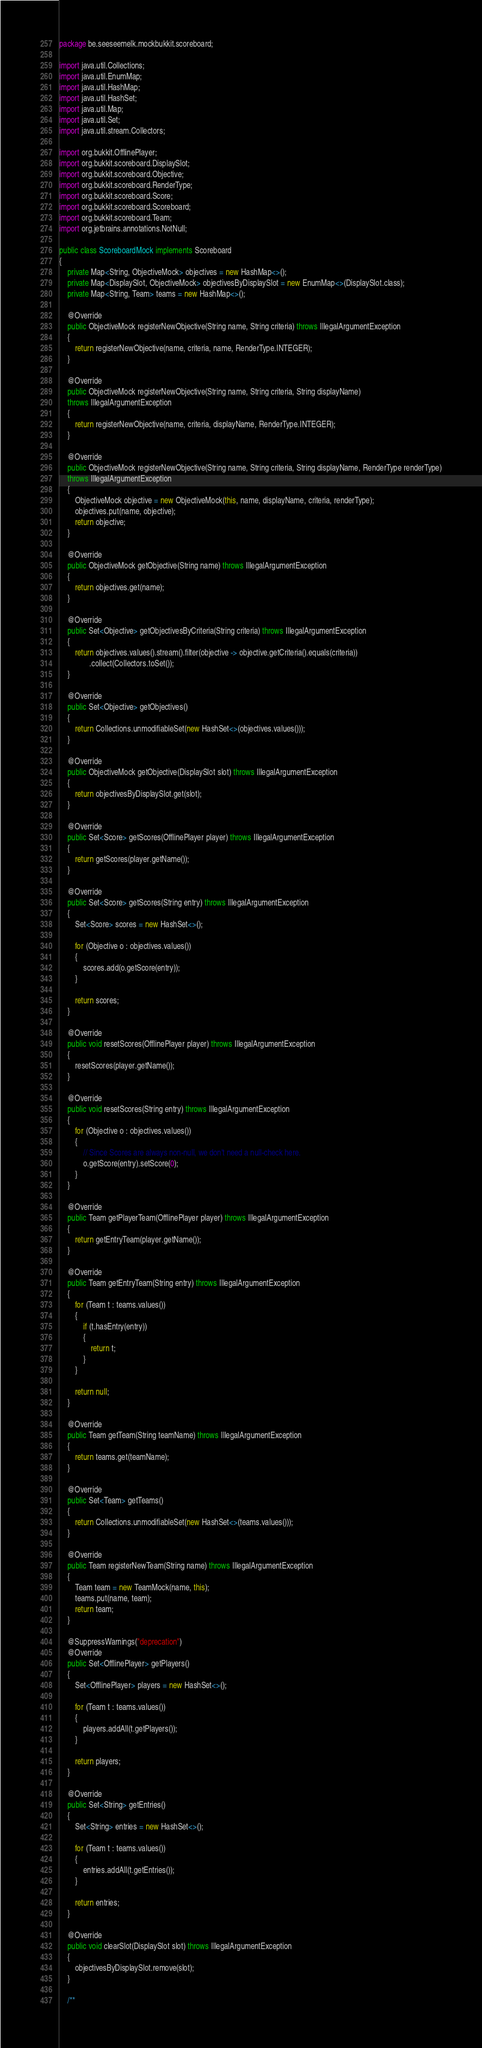Convert code to text. <code><loc_0><loc_0><loc_500><loc_500><_Java_>package be.seeseemelk.mockbukkit.scoreboard;

import java.util.Collections;
import java.util.EnumMap;
import java.util.HashMap;
import java.util.HashSet;
import java.util.Map;
import java.util.Set;
import java.util.stream.Collectors;

import org.bukkit.OfflinePlayer;
import org.bukkit.scoreboard.DisplaySlot;
import org.bukkit.scoreboard.Objective;
import org.bukkit.scoreboard.RenderType;
import org.bukkit.scoreboard.Score;
import org.bukkit.scoreboard.Scoreboard;
import org.bukkit.scoreboard.Team;
import org.jetbrains.annotations.NotNull;

public class ScoreboardMock implements Scoreboard
{
	private Map<String, ObjectiveMock> objectives = new HashMap<>();
	private Map<DisplaySlot, ObjectiveMock> objectivesByDisplaySlot = new EnumMap<>(DisplaySlot.class);
	private Map<String, Team> teams = new HashMap<>();

	@Override
	public ObjectiveMock registerNewObjective(String name, String criteria) throws IllegalArgumentException
	{
		return registerNewObjective(name, criteria, name, RenderType.INTEGER);
	}

	@Override
	public ObjectiveMock registerNewObjective(String name, String criteria, String displayName)
	throws IllegalArgumentException
	{
		return registerNewObjective(name, criteria, displayName, RenderType.INTEGER);
	}

	@Override
	public ObjectiveMock registerNewObjective(String name, String criteria, String displayName, RenderType renderType)
	throws IllegalArgumentException
	{
		ObjectiveMock objective = new ObjectiveMock(this, name, displayName, criteria, renderType);
		objectives.put(name, objective);
		return objective;
	}

	@Override
	public ObjectiveMock getObjective(String name) throws IllegalArgumentException
	{
		return objectives.get(name);
	}

	@Override
	public Set<Objective> getObjectivesByCriteria(String criteria) throws IllegalArgumentException
	{
		return objectives.values().stream().filter(objective -> objective.getCriteria().equals(criteria))
		       .collect(Collectors.toSet());
	}

	@Override
	public Set<Objective> getObjectives()
	{
		return Collections.unmodifiableSet(new HashSet<>(objectives.values()));
	}

	@Override
	public ObjectiveMock getObjective(DisplaySlot slot) throws IllegalArgumentException
	{
		return objectivesByDisplaySlot.get(slot);
	}

	@Override
	public Set<Score> getScores(OfflinePlayer player) throws IllegalArgumentException
	{
		return getScores(player.getName());
	}

	@Override
	public Set<Score> getScores(String entry) throws IllegalArgumentException
	{
		Set<Score> scores = new HashSet<>();

		for (Objective o : objectives.values())
		{
			scores.add(o.getScore(entry));
		}

		return scores;
	}

	@Override
	public void resetScores(OfflinePlayer player) throws IllegalArgumentException
	{
		resetScores(player.getName());
	}

	@Override
	public void resetScores(String entry) throws IllegalArgumentException
	{
		for (Objective o : objectives.values())
		{
			// Since Scores are always non-null, we don't need a null-check here.
			o.getScore(entry).setScore(0);
		}
	}

	@Override
	public Team getPlayerTeam(OfflinePlayer player) throws IllegalArgumentException
	{
		return getEntryTeam(player.getName());
	}

	@Override
	public Team getEntryTeam(String entry) throws IllegalArgumentException
	{
		for (Team t : teams.values())
		{
			if (t.hasEntry(entry))
			{
				return t;
			}
		}

		return null;
	}

	@Override
	public Team getTeam(String teamName) throws IllegalArgumentException
	{
		return teams.get(teamName);
	}

	@Override
	public Set<Team> getTeams()
	{
		return Collections.unmodifiableSet(new HashSet<>(teams.values()));
	}

	@Override
	public Team registerNewTeam(String name) throws IllegalArgumentException
	{
		Team team = new TeamMock(name, this);
		teams.put(name, team);
		return team;
	}

	@SuppressWarnings("deprecation")
	@Override
	public Set<OfflinePlayer> getPlayers()
	{
		Set<OfflinePlayer> players = new HashSet<>();

		for (Team t : teams.values())
		{
			players.addAll(t.getPlayers());
		}

		return players;
	}

	@Override
	public Set<String> getEntries()
	{
		Set<String> entries = new HashSet<>();

		for (Team t : teams.values())
		{
			entries.addAll(t.getEntries());
		}

		return entries;
	}

	@Override
	public void clearSlot(DisplaySlot slot) throws IllegalArgumentException
	{
		objectivesByDisplaySlot.remove(slot);
	}

	/**</code> 